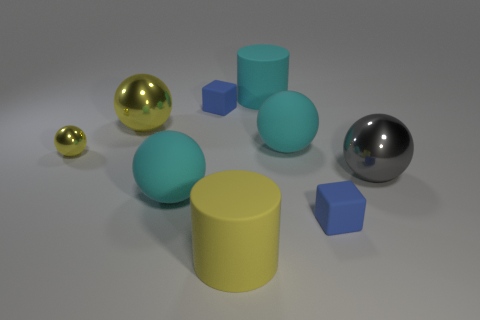Subtract all cylinders. How many objects are left? 7 Add 3 cyan rubber cylinders. How many cyan rubber cylinders exist? 4 Subtract 0 cyan cubes. How many objects are left? 9 Subtract all big yellow rubber things. Subtract all matte cubes. How many objects are left? 6 Add 5 big cyan rubber cylinders. How many big cyan rubber cylinders are left? 6 